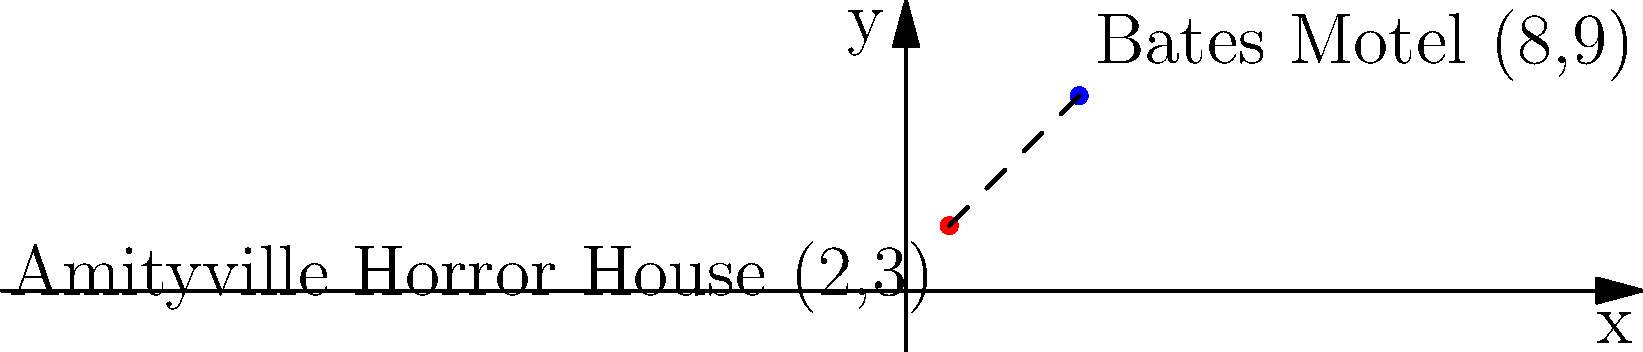In a retro horror movie marathon, you're planning a road trip between two iconic haunted houses: the Amityville Horror House and the Bates Motel from Psycho. On a coordinate plane, the Amityville Horror House is located at (2,3), while the Bates Motel is at (8,9). Using the distance formula, calculate the straight-line distance between these two famous horror movie locations. Round your answer to two decimal places. To solve this problem, we'll use the distance formula:

$$d = \sqrt{(x_2 - x_1)^2 + (y_2 - y_1)^2}$$

Where $(x_1, y_1)$ is the coordinate of the Amityville Horror House (2,3) and $(x_2, y_2)$ is the coordinate of the Bates Motel (8,9).

Step 1: Substitute the values into the formula:
$$d = \sqrt{(8 - 2)^2 + (9 - 3)^2}$$

Step 2: Simplify the expressions inside the parentheses:
$$d = \sqrt{6^2 + 6^2}$$

Step 3: Calculate the squares:
$$d = \sqrt{36 + 36}$$

Step 4: Add the values under the square root:
$$d = \sqrt{72}$$

Step 5: Simplify the square root:
$$d = 6\sqrt{2}$$

Step 6: Calculate the approximate value and round to two decimal places:
$$d \approx 8.49$$

Therefore, the straight-line distance between the Amityville Horror House and the Bates Motel is approximately 8.49 units.
Answer: 8.49 units 